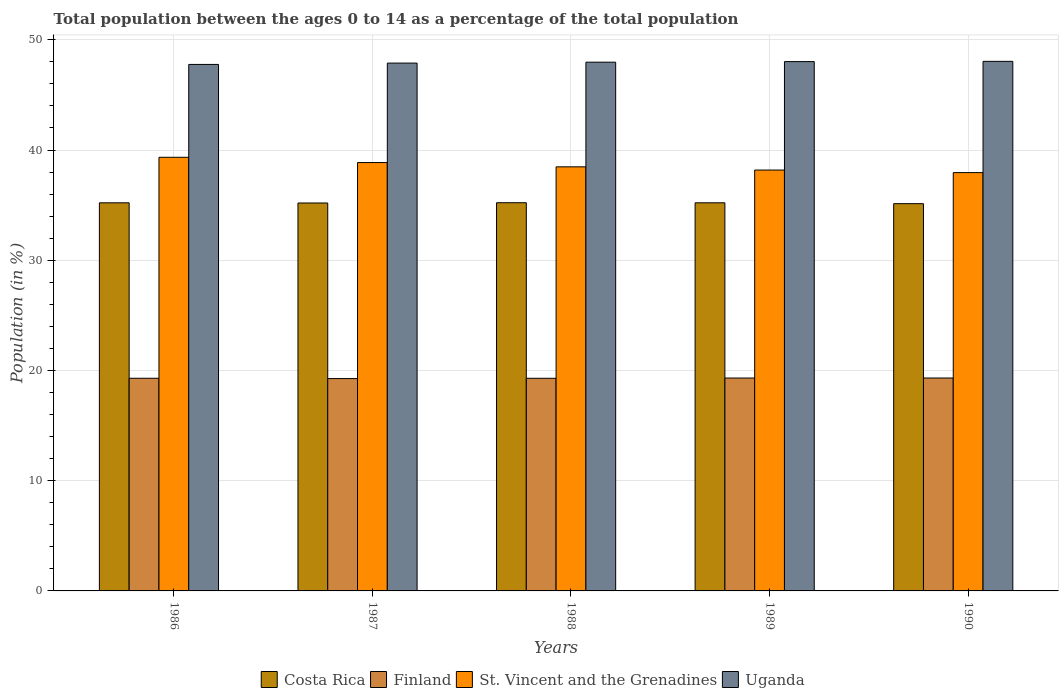How many different coloured bars are there?
Offer a terse response. 4. Are the number of bars per tick equal to the number of legend labels?
Your response must be concise. Yes. Are the number of bars on each tick of the X-axis equal?
Provide a succinct answer. Yes. What is the label of the 4th group of bars from the left?
Offer a very short reply. 1989. In how many cases, is the number of bars for a given year not equal to the number of legend labels?
Your answer should be compact. 0. What is the percentage of the population ages 0 to 14 in Costa Rica in 1989?
Your response must be concise. 35.21. Across all years, what is the maximum percentage of the population ages 0 to 14 in Finland?
Provide a succinct answer. 19.32. Across all years, what is the minimum percentage of the population ages 0 to 14 in St. Vincent and the Grenadines?
Your answer should be very brief. 37.95. In which year was the percentage of the population ages 0 to 14 in St. Vincent and the Grenadines maximum?
Provide a short and direct response. 1986. What is the total percentage of the population ages 0 to 14 in Finland in the graph?
Make the answer very short. 96.48. What is the difference between the percentage of the population ages 0 to 14 in Uganda in 1987 and that in 1990?
Ensure brevity in your answer.  -0.16. What is the difference between the percentage of the population ages 0 to 14 in St. Vincent and the Grenadines in 1988 and the percentage of the population ages 0 to 14 in Costa Rica in 1990?
Keep it short and to the point. 3.34. What is the average percentage of the population ages 0 to 14 in Finland per year?
Make the answer very short. 19.3. In the year 1990, what is the difference between the percentage of the population ages 0 to 14 in Costa Rica and percentage of the population ages 0 to 14 in Uganda?
Ensure brevity in your answer.  -12.91. In how many years, is the percentage of the population ages 0 to 14 in Costa Rica greater than 8?
Your answer should be compact. 5. What is the ratio of the percentage of the population ages 0 to 14 in Uganda in 1986 to that in 1987?
Your answer should be very brief. 1. Is the percentage of the population ages 0 to 14 in Costa Rica in 1986 less than that in 1990?
Make the answer very short. No. Is the difference between the percentage of the population ages 0 to 14 in Costa Rica in 1986 and 1988 greater than the difference between the percentage of the population ages 0 to 14 in Uganda in 1986 and 1988?
Keep it short and to the point. Yes. What is the difference between the highest and the second highest percentage of the population ages 0 to 14 in Finland?
Offer a terse response. 0. What is the difference between the highest and the lowest percentage of the population ages 0 to 14 in Costa Rica?
Offer a terse response. 0.09. What does the 1st bar from the left in 1989 represents?
Offer a very short reply. Costa Rica. What does the 1st bar from the right in 1988 represents?
Ensure brevity in your answer.  Uganda. How many bars are there?
Your response must be concise. 20. How many years are there in the graph?
Your answer should be compact. 5. Does the graph contain any zero values?
Your response must be concise. No. Does the graph contain grids?
Offer a terse response. Yes. Where does the legend appear in the graph?
Your answer should be very brief. Bottom center. How many legend labels are there?
Your answer should be very brief. 4. What is the title of the graph?
Provide a short and direct response. Total population between the ages 0 to 14 as a percentage of the total population. Does "Senegal" appear as one of the legend labels in the graph?
Provide a succinct answer. No. What is the label or title of the Y-axis?
Make the answer very short. Population (in %). What is the Population (in %) of Costa Rica in 1986?
Provide a succinct answer. 35.21. What is the Population (in %) of Finland in 1986?
Provide a short and direct response. 19.29. What is the Population (in %) in St. Vincent and the Grenadines in 1986?
Make the answer very short. 39.34. What is the Population (in %) of Uganda in 1986?
Offer a very short reply. 47.76. What is the Population (in %) in Costa Rica in 1987?
Your response must be concise. 35.19. What is the Population (in %) in Finland in 1987?
Your response must be concise. 19.27. What is the Population (in %) of St. Vincent and the Grenadines in 1987?
Offer a very short reply. 38.86. What is the Population (in %) in Uganda in 1987?
Give a very brief answer. 47.89. What is the Population (in %) in Costa Rica in 1988?
Provide a short and direct response. 35.22. What is the Population (in %) of Finland in 1988?
Ensure brevity in your answer.  19.29. What is the Population (in %) of St. Vincent and the Grenadines in 1988?
Provide a short and direct response. 38.47. What is the Population (in %) in Uganda in 1988?
Provide a short and direct response. 47.97. What is the Population (in %) in Costa Rica in 1989?
Make the answer very short. 35.21. What is the Population (in %) of Finland in 1989?
Make the answer very short. 19.31. What is the Population (in %) of St. Vincent and the Grenadines in 1989?
Offer a terse response. 38.18. What is the Population (in %) in Uganda in 1989?
Provide a short and direct response. 48.02. What is the Population (in %) of Costa Rica in 1990?
Ensure brevity in your answer.  35.13. What is the Population (in %) of Finland in 1990?
Ensure brevity in your answer.  19.32. What is the Population (in %) in St. Vincent and the Grenadines in 1990?
Give a very brief answer. 37.95. What is the Population (in %) in Uganda in 1990?
Give a very brief answer. 48.04. Across all years, what is the maximum Population (in %) of Costa Rica?
Your answer should be compact. 35.22. Across all years, what is the maximum Population (in %) of Finland?
Keep it short and to the point. 19.32. Across all years, what is the maximum Population (in %) in St. Vincent and the Grenadines?
Give a very brief answer. 39.34. Across all years, what is the maximum Population (in %) in Uganda?
Your answer should be compact. 48.04. Across all years, what is the minimum Population (in %) of Costa Rica?
Provide a short and direct response. 35.13. Across all years, what is the minimum Population (in %) of Finland?
Keep it short and to the point. 19.27. Across all years, what is the minimum Population (in %) in St. Vincent and the Grenadines?
Your answer should be compact. 37.95. Across all years, what is the minimum Population (in %) of Uganda?
Your response must be concise. 47.76. What is the total Population (in %) in Costa Rica in the graph?
Offer a terse response. 175.96. What is the total Population (in %) of Finland in the graph?
Provide a succinct answer. 96.48. What is the total Population (in %) of St. Vincent and the Grenadines in the graph?
Provide a short and direct response. 192.81. What is the total Population (in %) in Uganda in the graph?
Your answer should be very brief. 239.68. What is the difference between the Population (in %) in Costa Rica in 1986 and that in 1987?
Your answer should be compact. 0.01. What is the difference between the Population (in %) in Finland in 1986 and that in 1987?
Offer a very short reply. 0.03. What is the difference between the Population (in %) in St. Vincent and the Grenadines in 1986 and that in 1987?
Make the answer very short. 0.48. What is the difference between the Population (in %) of Uganda in 1986 and that in 1987?
Your answer should be compact. -0.12. What is the difference between the Population (in %) of Costa Rica in 1986 and that in 1988?
Keep it short and to the point. -0.01. What is the difference between the Population (in %) of Finland in 1986 and that in 1988?
Your response must be concise. 0. What is the difference between the Population (in %) in St. Vincent and the Grenadines in 1986 and that in 1988?
Offer a terse response. 0.87. What is the difference between the Population (in %) of Uganda in 1986 and that in 1988?
Make the answer very short. -0.2. What is the difference between the Population (in %) of Costa Rica in 1986 and that in 1989?
Your answer should be very brief. -0. What is the difference between the Population (in %) of Finland in 1986 and that in 1989?
Provide a succinct answer. -0.02. What is the difference between the Population (in %) of St. Vincent and the Grenadines in 1986 and that in 1989?
Ensure brevity in your answer.  1.16. What is the difference between the Population (in %) of Uganda in 1986 and that in 1989?
Provide a succinct answer. -0.26. What is the difference between the Population (in %) in Costa Rica in 1986 and that in 1990?
Provide a succinct answer. 0.08. What is the difference between the Population (in %) of Finland in 1986 and that in 1990?
Provide a short and direct response. -0.02. What is the difference between the Population (in %) in St. Vincent and the Grenadines in 1986 and that in 1990?
Keep it short and to the point. 1.39. What is the difference between the Population (in %) in Uganda in 1986 and that in 1990?
Keep it short and to the point. -0.28. What is the difference between the Population (in %) of Costa Rica in 1987 and that in 1988?
Your response must be concise. -0.02. What is the difference between the Population (in %) in Finland in 1987 and that in 1988?
Give a very brief answer. -0.03. What is the difference between the Population (in %) in St. Vincent and the Grenadines in 1987 and that in 1988?
Ensure brevity in your answer.  0.39. What is the difference between the Population (in %) in Uganda in 1987 and that in 1988?
Your answer should be very brief. -0.08. What is the difference between the Population (in %) in Costa Rica in 1987 and that in 1989?
Offer a very short reply. -0.02. What is the difference between the Population (in %) in Finland in 1987 and that in 1989?
Your response must be concise. -0.05. What is the difference between the Population (in %) in St. Vincent and the Grenadines in 1987 and that in 1989?
Make the answer very short. 0.68. What is the difference between the Population (in %) in Uganda in 1987 and that in 1989?
Make the answer very short. -0.13. What is the difference between the Population (in %) of Costa Rica in 1987 and that in 1990?
Provide a short and direct response. 0.06. What is the difference between the Population (in %) in Finland in 1987 and that in 1990?
Give a very brief answer. -0.05. What is the difference between the Population (in %) of St. Vincent and the Grenadines in 1987 and that in 1990?
Ensure brevity in your answer.  0.91. What is the difference between the Population (in %) of Uganda in 1987 and that in 1990?
Your response must be concise. -0.16. What is the difference between the Population (in %) in Costa Rica in 1988 and that in 1989?
Your answer should be very brief. 0.01. What is the difference between the Population (in %) of Finland in 1988 and that in 1989?
Keep it short and to the point. -0.02. What is the difference between the Population (in %) of St. Vincent and the Grenadines in 1988 and that in 1989?
Ensure brevity in your answer.  0.29. What is the difference between the Population (in %) in Uganda in 1988 and that in 1989?
Your response must be concise. -0.05. What is the difference between the Population (in %) in Costa Rica in 1988 and that in 1990?
Provide a short and direct response. 0.09. What is the difference between the Population (in %) in Finland in 1988 and that in 1990?
Offer a terse response. -0.03. What is the difference between the Population (in %) of St. Vincent and the Grenadines in 1988 and that in 1990?
Your response must be concise. 0.52. What is the difference between the Population (in %) of Uganda in 1988 and that in 1990?
Provide a short and direct response. -0.08. What is the difference between the Population (in %) of Costa Rica in 1989 and that in 1990?
Provide a succinct answer. 0.08. What is the difference between the Population (in %) of Finland in 1989 and that in 1990?
Provide a short and direct response. -0. What is the difference between the Population (in %) of St. Vincent and the Grenadines in 1989 and that in 1990?
Offer a terse response. 0.23. What is the difference between the Population (in %) of Uganda in 1989 and that in 1990?
Your answer should be very brief. -0.02. What is the difference between the Population (in %) in Costa Rica in 1986 and the Population (in %) in Finland in 1987?
Keep it short and to the point. 15.94. What is the difference between the Population (in %) of Costa Rica in 1986 and the Population (in %) of St. Vincent and the Grenadines in 1987?
Offer a terse response. -3.65. What is the difference between the Population (in %) of Costa Rica in 1986 and the Population (in %) of Uganda in 1987?
Provide a succinct answer. -12.68. What is the difference between the Population (in %) in Finland in 1986 and the Population (in %) in St. Vincent and the Grenadines in 1987?
Offer a very short reply. -19.57. What is the difference between the Population (in %) in Finland in 1986 and the Population (in %) in Uganda in 1987?
Provide a succinct answer. -28.59. What is the difference between the Population (in %) in St. Vincent and the Grenadines in 1986 and the Population (in %) in Uganda in 1987?
Make the answer very short. -8.55. What is the difference between the Population (in %) in Costa Rica in 1986 and the Population (in %) in Finland in 1988?
Offer a very short reply. 15.92. What is the difference between the Population (in %) in Costa Rica in 1986 and the Population (in %) in St. Vincent and the Grenadines in 1988?
Your answer should be very brief. -3.26. What is the difference between the Population (in %) in Costa Rica in 1986 and the Population (in %) in Uganda in 1988?
Keep it short and to the point. -12.76. What is the difference between the Population (in %) of Finland in 1986 and the Population (in %) of St. Vincent and the Grenadines in 1988?
Make the answer very short. -19.18. What is the difference between the Population (in %) of Finland in 1986 and the Population (in %) of Uganda in 1988?
Your answer should be compact. -28.68. What is the difference between the Population (in %) of St. Vincent and the Grenadines in 1986 and the Population (in %) of Uganda in 1988?
Your answer should be very brief. -8.63. What is the difference between the Population (in %) of Costa Rica in 1986 and the Population (in %) of Finland in 1989?
Your response must be concise. 15.89. What is the difference between the Population (in %) of Costa Rica in 1986 and the Population (in %) of St. Vincent and the Grenadines in 1989?
Your response must be concise. -2.97. What is the difference between the Population (in %) of Costa Rica in 1986 and the Population (in %) of Uganda in 1989?
Offer a very short reply. -12.81. What is the difference between the Population (in %) of Finland in 1986 and the Population (in %) of St. Vincent and the Grenadines in 1989?
Offer a terse response. -18.89. What is the difference between the Population (in %) in Finland in 1986 and the Population (in %) in Uganda in 1989?
Make the answer very short. -28.73. What is the difference between the Population (in %) in St. Vincent and the Grenadines in 1986 and the Population (in %) in Uganda in 1989?
Give a very brief answer. -8.68. What is the difference between the Population (in %) in Costa Rica in 1986 and the Population (in %) in Finland in 1990?
Your response must be concise. 15.89. What is the difference between the Population (in %) of Costa Rica in 1986 and the Population (in %) of St. Vincent and the Grenadines in 1990?
Ensure brevity in your answer.  -2.74. What is the difference between the Population (in %) in Costa Rica in 1986 and the Population (in %) in Uganda in 1990?
Offer a terse response. -12.83. What is the difference between the Population (in %) of Finland in 1986 and the Population (in %) of St. Vincent and the Grenadines in 1990?
Ensure brevity in your answer.  -18.66. What is the difference between the Population (in %) of Finland in 1986 and the Population (in %) of Uganda in 1990?
Give a very brief answer. -28.75. What is the difference between the Population (in %) in St. Vincent and the Grenadines in 1986 and the Population (in %) in Uganda in 1990?
Your answer should be compact. -8.7. What is the difference between the Population (in %) of Costa Rica in 1987 and the Population (in %) of Finland in 1988?
Make the answer very short. 15.9. What is the difference between the Population (in %) of Costa Rica in 1987 and the Population (in %) of St. Vincent and the Grenadines in 1988?
Your answer should be compact. -3.28. What is the difference between the Population (in %) of Costa Rica in 1987 and the Population (in %) of Uganda in 1988?
Offer a terse response. -12.77. What is the difference between the Population (in %) of Finland in 1987 and the Population (in %) of St. Vincent and the Grenadines in 1988?
Give a very brief answer. -19.21. What is the difference between the Population (in %) of Finland in 1987 and the Population (in %) of Uganda in 1988?
Give a very brief answer. -28.7. What is the difference between the Population (in %) of St. Vincent and the Grenadines in 1987 and the Population (in %) of Uganda in 1988?
Your response must be concise. -9.11. What is the difference between the Population (in %) of Costa Rica in 1987 and the Population (in %) of Finland in 1989?
Offer a very short reply. 15.88. What is the difference between the Population (in %) in Costa Rica in 1987 and the Population (in %) in St. Vincent and the Grenadines in 1989?
Give a very brief answer. -2.99. What is the difference between the Population (in %) of Costa Rica in 1987 and the Population (in %) of Uganda in 1989?
Provide a succinct answer. -12.83. What is the difference between the Population (in %) of Finland in 1987 and the Population (in %) of St. Vincent and the Grenadines in 1989?
Your answer should be very brief. -18.92. What is the difference between the Population (in %) of Finland in 1987 and the Population (in %) of Uganda in 1989?
Ensure brevity in your answer.  -28.75. What is the difference between the Population (in %) in St. Vincent and the Grenadines in 1987 and the Population (in %) in Uganda in 1989?
Provide a short and direct response. -9.16. What is the difference between the Population (in %) of Costa Rica in 1987 and the Population (in %) of Finland in 1990?
Your response must be concise. 15.88. What is the difference between the Population (in %) of Costa Rica in 1987 and the Population (in %) of St. Vincent and the Grenadines in 1990?
Offer a terse response. -2.76. What is the difference between the Population (in %) in Costa Rica in 1987 and the Population (in %) in Uganda in 1990?
Your answer should be compact. -12.85. What is the difference between the Population (in %) of Finland in 1987 and the Population (in %) of St. Vincent and the Grenadines in 1990?
Provide a succinct answer. -18.69. What is the difference between the Population (in %) in Finland in 1987 and the Population (in %) in Uganda in 1990?
Offer a terse response. -28.78. What is the difference between the Population (in %) in St. Vincent and the Grenadines in 1987 and the Population (in %) in Uganda in 1990?
Offer a terse response. -9.18. What is the difference between the Population (in %) of Costa Rica in 1988 and the Population (in %) of Finland in 1989?
Your answer should be very brief. 15.9. What is the difference between the Population (in %) in Costa Rica in 1988 and the Population (in %) in St. Vincent and the Grenadines in 1989?
Your answer should be very brief. -2.96. What is the difference between the Population (in %) of Costa Rica in 1988 and the Population (in %) of Uganda in 1989?
Your response must be concise. -12.8. What is the difference between the Population (in %) in Finland in 1988 and the Population (in %) in St. Vincent and the Grenadines in 1989?
Your response must be concise. -18.89. What is the difference between the Population (in %) of Finland in 1988 and the Population (in %) of Uganda in 1989?
Give a very brief answer. -28.73. What is the difference between the Population (in %) of St. Vincent and the Grenadines in 1988 and the Population (in %) of Uganda in 1989?
Provide a succinct answer. -9.55. What is the difference between the Population (in %) in Costa Rica in 1988 and the Population (in %) in Finland in 1990?
Provide a short and direct response. 15.9. What is the difference between the Population (in %) in Costa Rica in 1988 and the Population (in %) in St. Vincent and the Grenadines in 1990?
Give a very brief answer. -2.73. What is the difference between the Population (in %) in Costa Rica in 1988 and the Population (in %) in Uganda in 1990?
Your response must be concise. -12.83. What is the difference between the Population (in %) in Finland in 1988 and the Population (in %) in St. Vincent and the Grenadines in 1990?
Keep it short and to the point. -18.66. What is the difference between the Population (in %) in Finland in 1988 and the Population (in %) in Uganda in 1990?
Offer a very short reply. -28.75. What is the difference between the Population (in %) in St. Vincent and the Grenadines in 1988 and the Population (in %) in Uganda in 1990?
Offer a very short reply. -9.57. What is the difference between the Population (in %) in Costa Rica in 1989 and the Population (in %) in Finland in 1990?
Make the answer very short. 15.89. What is the difference between the Population (in %) in Costa Rica in 1989 and the Population (in %) in St. Vincent and the Grenadines in 1990?
Your answer should be compact. -2.74. What is the difference between the Population (in %) in Costa Rica in 1989 and the Population (in %) in Uganda in 1990?
Ensure brevity in your answer.  -12.83. What is the difference between the Population (in %) in Finland in 1989 and the Population (in %) in St. Vincent and the Grenadines in 1990?
Ensure brevity in your answer.  -18.64. What is the difference between the Population (in %) of Finland in 1989 and the Population (in %) of Uganda in 1990?
Give a very brief answer. -28.73. What is the difference between the Population (in %) of St. Vincent and the Grenadines in 1989 and the Population (in %) of Uganda in 1990?
Keep it short and to the point. -9.86. What is the average Population (in %) of Costa Rica per year?
Your response must be concise. 35.19. What is the average Population (in %) in Finland per year?
Your answer should be compact. 19.3. What is the average Population (in %) of St. Vincent and the Grenadines per year?
Your answer should be very brief. 38.56. What is the average Population (in %) of Uganda per year?
Offer a very short reply. 47.94. In the year 1986, what is the difference between the Population (in %) of Costa Rica and Population (in %) of Finland?
Keep it short and to the point. 15.92. In the year 1986, what is the difference between the Population (in %) of Costa Rica and Population (in %) of St. Vincent and the Grenadines?
Your answer should be very brief. -4.13. In the year 1986, what is the difference between the Population (in %) of Costa Rica and Population (in %) of Uganda?
Your answer should be very brief. -12.55. In the year 1986, what is the difference between the Population (in %) of Finland and Population (in %) of St. Vincent and the Grenadines?
Keep it short and to the point. -20.05. In the year 1986, what is the difference between the Population (in %) in Finland and Population (in %) in Uganda?
Your response must be concise. -28.47. In the year 1986, what is the difference between the Population (in %) in St. Vincent and the Grenadines and Population (in %) in Uganda?
Ensure brevity in your answer.  -8.42. In the year 1987, what is the difference between the Population (in %) in Costa Rica and Population (in %) in Finland?
Offer a very short reply. 15.93. In the year 1987, what is the difference between the Population (in %) in Costa Rica and Population (in %) in St. Vincent and the Grenadines?
Provide a short and direct response. -3.67. In the year 1987, what is the difference between the Population (in %) of Costa Rica and Population (in %) of Uganda?
Provide a short and direct response. -12.69. In the year 1987, what is the difference between the Population (in %) of Finland and Population (in %) of St. Vincent and the Grenadines?
Your answer should be very brief. -19.6. In the year 1987, what is the difference between the Population (in %) of Finland and Population (in %) of Uganda?
Your response must be concise. -28.62. In the year 1987, what is the difference between the Population (in %) in St. Vincent and the Grenadines and Population (in %) in Uganda?
Your response must be concise. -9.02. In the year 1988, what is the difference between the Population (in %) of Costa Rica and Population (in %) of Finland?
Provide a short and direct response. 15.93. In the year 1988, what is the difference between the Population (in %) of Costa Rica and Population (in %) of St. Vincent and the Grenadines?
Offer a very short reply. -3.26. In the year 1988, what is the difference between the Population (in %) in Costa Rica and Population (in %) in Uganda?
Ensure brevity in your answer.  -12.75. In the year 1988, what is the difference between the Population (in %) of Finland and Population (in %) of St. Vincent and the Grenadines?
Offer a very short reply. -19.18. In the year 1988, what is the difference between the Population (in %) in Finland and Population (in %) in Uganda?
Provide a succinct answer. -28.68. In the year 1988, what is the difference between the Population (in %) of St. Vincent and the Grenadines and Population (in %) of Uganda?
Offer a terse response. -9.49. In the year 1989, what is the difference between the Population (in %) in Costa Rica and Population (in %) in Finland?
Your answer should be very brief. 15.9. In the year 1989, what is the difference between the Population (in %) of Costa Rica and Population (in %) of St. Vincent and the Grenadines?
Provide a short and direct response. -2.97. In the year 1989, what is the difference between the Population (in %) of Costa Rica and Population (in %) of Uganda?
Your answer should be very brief. -12.81. In the year 1989, what is the difference between the Population (in %) of Finland and Population (in %) of St. Vincent and the Grenadines?
Your answer should be very brief. -18.87. In the year 1989, what is the difference between the Population (in %) in Finland and Population (in %) in Uganda?
Offer a very short reply. -28.71. In the year 1989, what is the difference between the Population (in %) in St. Vincent and the Grenadines and Population (in %) in Uganda?
Your answer should be compact. -9.84. In the year 1990, what is the difference between the Population (in %) of Costa Rica and Population (in %) of Finland?
Offer a terse response. 15.82. In the year 1990, what is the difference between the Population (in %) of Costa Rica and Population (in %) of St. Vincent and the Grenadines?
Your response must be concise. -2.82. In the year 1990, what is the difference between the Population (in %) in Costa Rica and Population (in %) in Uganda?
Make the answer very short. -12.91. In the year 1990, what is the difference between the Population (in %) of Finland and Population (in %) of St. Vincent and the Grenadines?
Give a very brief answer. -18.64. In the year 1990, what is the difference between the Population (in %) of Finland and Population (in %) of Uganda?
Your answer should be compact. -28.73. In the year 1990, what is the difference between the Population (in %) in St. Vincent and the Grenadines and Population (in %) in Uganda?
Give a very brief answer. -10.09. What is the ratio of the Population (in %) of St. Vincent and the Grenadines in 1986 to that in 1987?
Your answer should be very brief. 1.01. What is the ratio of the Population (in %) in Uganda in 1986 to that in 1987?
Offer a terse response. 1. What is the ratio of the Population (in %) in Costa Rica in 1986 to that in 1988?
Make the answer very short. 1. What is the ratio of the Population (in %) in St. Vincent and the Grenadines in 1986 to that in 1988?
Provide a succinct answer. 1.02. What is the ratio of the Population (in %) in Costa Rica in 1986 to that in 1989?
Your answer should be compact. 1. What is the ratio of the Population (in %) of Finland in 1986 to that in 1989?
Make the answer very short. 1. What is the ratio of the Population (in %) in St. Vincent and the Grenadines in 1986 to that in 1989?
Your answer should be very brief. 1.03. What is the ratio of the Population (in %) in Uganda in 1986 to that in 1989?
Provide a short and direct response. 0.99. What is the ratio of the Population (in %) in Finland in 1986 to that in 1990?
Your answer should be very brief. 1. What is the ratio of the Population (in %) of St. Vincent and the Grenadines in 1986 to that in 1990?
Offer a very short reply. 1.04. What is the ratio of the Population (in %) in Costa Rica in 1987 to that in 1988?
Provide a short and direct response. 1. What is the ratio of the Population (in %) of Finland in 1987 to that in 1988?
Make the answer very short. 1. What is the ratio of the Population (in %) of St. Vincent and the Grenadines in 1987 to that in 1988?
Provide a succinct answer. 1.01. What is the ratio of the Population (in %) in Uganda in 1987 to that in 1988?
Provide a succinct answer. 1. What is the ratio of the Population (in %) of Costa Rica in 1987 to that in 1989?
Offer a terse response. 1. What is the ratio of the Population (in %) of St. Vincent and the Grenadines in 1987 to that in 1989?
Provide a succinct answer. 1.02. What is the ratio of the Population (in %) in Costa Rica in 1987 to that in 1990?
Offer a terse response. 1. What is the ratio of the Population (in %) of Uganda in 1987 to that in 1990?
Provide a succinct answer. 1. What is the ratio of the Population (in %) in St. Vincent and the Grenadines in 1988 to that in 1989?
Your answer should be very brief. 1.01. What is the ratio of the Population (in %) of Uganda in 1988 to that in 1989?
Provide a short and direct response. 1. What is the ratio of the Population (in %) of Costa Rica in 1988 to that in 1990?
Make the answer very short. 1. What is the ratio of the Population (in %) of St. Vincent and the Grenadines in 1988 to that in 1990?
Ensure brevity in your answer.  1.01. What is the ratio of the Population (in %) of Uganda in 1988 to that in 1990?
Your response must be concise. 1. What is the ratio of the Population (in %) of Costa Rica in 1989 to that in 1990?
Your response must be concise. 1. What is the ratio of the Population (in %) in Finland in 1989 to that in 1990?
Give a very brief answer. 1. What is the ratio of the Population (in %) in St. Vincent and the Grenadines in 1989 to that in 1990?
Your answer should be compact. 1.01. What is the difference between the highest and the second highest Population (in %) in Costa Rica?
Offer a very short reply. 0.01. What is the difference between the highest and the second highest Population (in %) of Finland?
Offer a terse response. 0. What is the difference between the highest and the second highest Population (in %) in St. Vincent and the Grenadines?
Your response must be concise. 0.48. What is the difference between the highest and the second highest Population (in %) of Uganda?
Give a very brief answer. 0.02. What is the difference between the highest and the lowest Population (in %) of Costa Rica?
Offer a terse response. 0.09. What is the difference between the highest and the lowest Population (in %) of Finland?
Offer a very short reply. 0.05. What is the difference between the highest and the lowest Population (in %) in St. Vincent and the Grenadines?
Provide a succinct answer. 1.39. What is the difference between the highest and the lowest Population (in %) in Uganda?
Your answer should be compact. 0.28. 